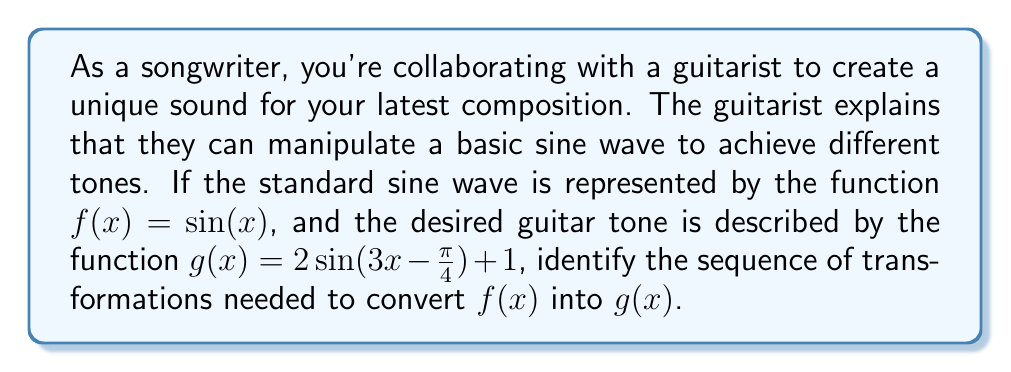Teach me how to tackle this problem. To transform $f(x) = \sin(x)$ into $g(x) = 2\sin(3x - \frac{\pi}{4}) + 1$, we need to apply a series of transformations. Let's break it down step by step:

1. Inside the sine function:
   a. Horizontal stretch: The factor 3 in $3x$ indicates a horizontal compression by a factor of 3.
   b. Phase shift: The $-\frac{\pi}{4}$ inside the sine function represents a phase shift of $\frac{\pi}{4}$ units to the right.

2. Outside the sine function:
   a. Vertical stretch: The factor 2 outside $\sin(3x - \frac{\pi}{4})$ indicates a vertical stretch by a factor of 2.
   b. Vertical shift: The +1 at the end represents a vertical shift of 1 unit upward.

The order of applying these transformations matters. The correct sequence is:

1. Apply the horizontal compression: $\sin(3x)$
2. Apply the phase shift: $\sin(3x - \frac{\pi}{4})$
3. Apply the vertical stretch: $2\sin(3x - \frac{\pi}{4})$
4. Apply the vertical shift: $2\sin(3x - \frac{\pi}{4}) + 1$

This sequence of transformations will convert the basic sine wave into the desired guitar tone.
Answer: The sequence of transformations needed to convert $f(x) = \sin(x)$ into $g(x) = 2\sin(3x - \frac{\pi}{4}) + 1$ is:
1. Horizontal compression by a factor of 3
2. Phase shift $\frac{\pi}{4}$ units to the right
3. Vertical stretch by a factor of 2
4. Vertical shift 1 unit upward 